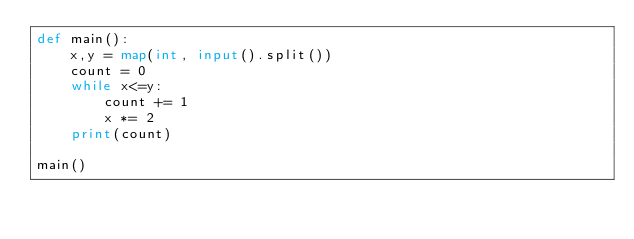<code> <loc_0><loc_0><loc_500><loc_500><_Python_>def main():
    x,y = map(int, input().split())
    count = 0
    while x<=y:
        count += 1
        x *= 2
    print(count)

main()
</code> 